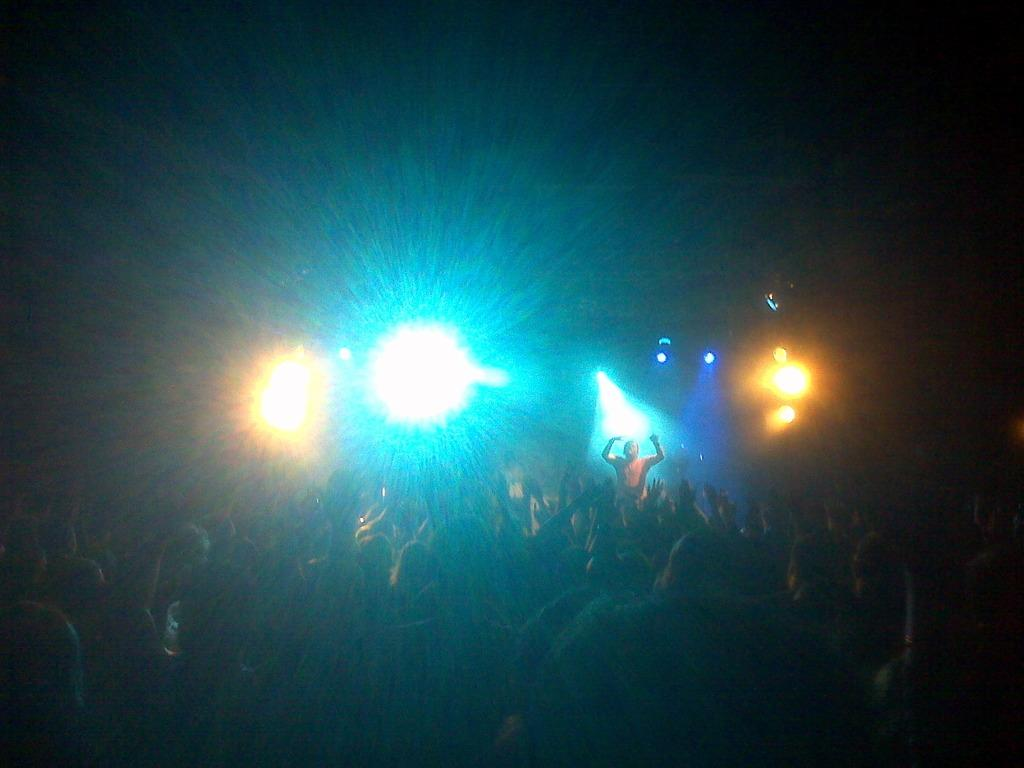How many people are in the image? There is a group of people in the image, but the exact number is not specified. What are the people in the image doing? The people are standing in the image. What can be seen in the background of the image? There are lights visible in the background of the image. What type of lock is being used to secure the potato in the image? There is no potato or lock present in the image. Is the group of people in the image affected by the rainstorm? There is no rainstorm depicted in the image. 